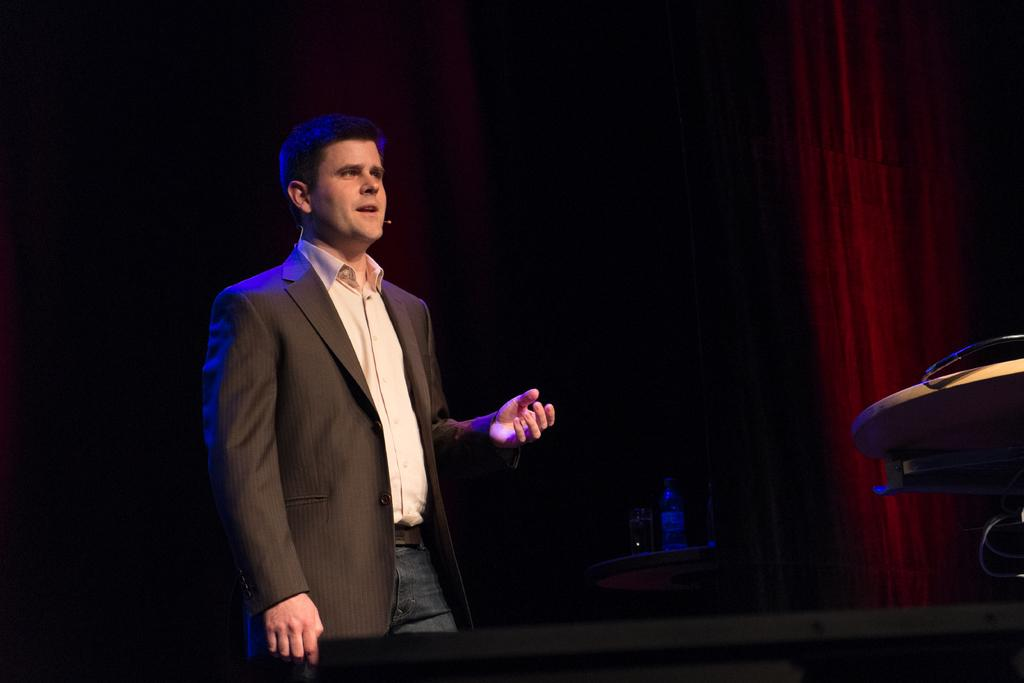What is the main subject of the image? The main subject of the image is a man. What is the man wearing in the image? The man is wearing a blazer in the image. What is the man doing in the image? The man is talking on a microphone in the image. What objects can be seen near the man? There is a bottle and a glass in the image. What type of background is present in the image? The background of the image is dark. What is the color of the curtain in the image? The curtain in the image is red. What type of voyage is the man embarking on in the image? There is no indication of a voyage in the image; the man is talking on a microphone. What arithmetic problem is the man solving in the image? There is no arithmetic problem present in the image; the man is talking on a microphone. 